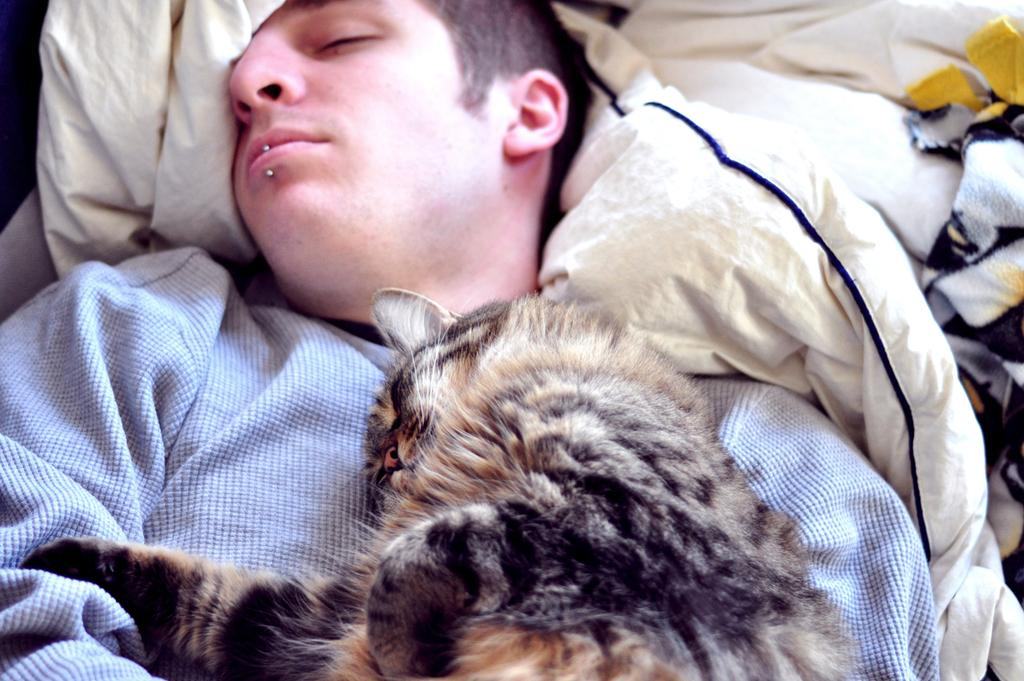Who is present in the image? There is a man in the image. What is on the man's chest? There is a cat on the man's chest. What else can be seen in the image besides the man and the cat? Clothes are visible in the image. What type of railway can be seen in the image? There is no railway present in the image. How many snakes are visible in the image? There are no snakes visible in the image. 